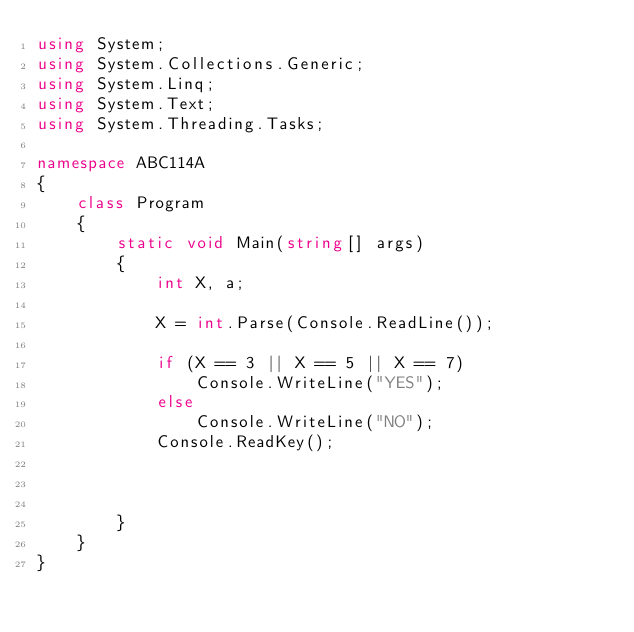Convert code to text. <code><loc_0><loc_0><loc_500><loc_500><_C#_>using System;
using System.Collections.Generic;
using System.Linq;
using System.Text;
using System.Threading.Tasks;

namespace ABC114A
{
    class Program
    {
        static void Main(string[] args)
        {
            int X, a;

            X = int.Parse(Console.ReadLine());

            if (X == 3 || X == 5 || X == 7)
                Console.WriteLine("YES");
            else
                Console.WriteLine("NO");
            Console.ReadKey();



        }
    }
}
</code> 